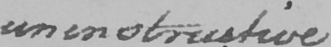Transcribe the text shown in this historical manuscript line. uninstructive 